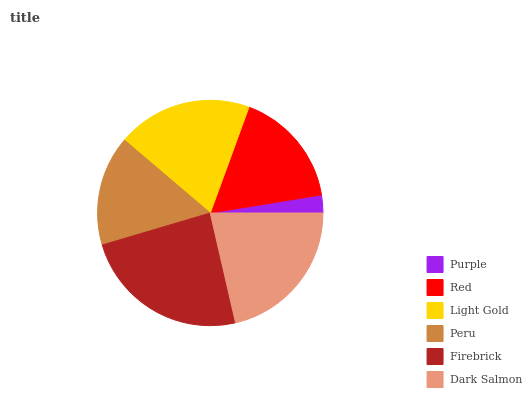Is Purple the minimum?
Answer yes or no. Yes. Is Firebrick the maximum?
Answer yes or no. Yes. Is Red the minimum?
Answer yes or no. No. Is Red the maximum?
Answer yes or no. No. Is Red greater than Purple?
Answer yes or no. Yes. Is Purple less than Red?
Answer yes or no. Yes. Is Purple greater than Red?
Answer yes or no. No. Is Red less than Purple?
Answer yes or no. No. Is Light Gold the high median?
Answer yes or no. Yes. Is Red the low median?
Answer yes or no. Yes. Is Dark Salmon the high median?
Answer yes or no. No. Is Light Gold the low median?
Answer yes or no. No. 